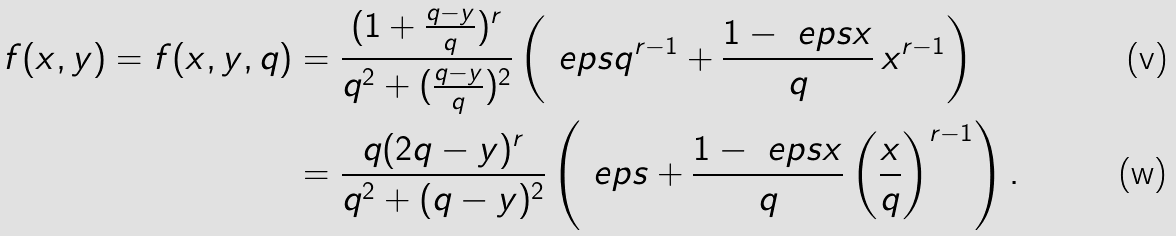Convert formula to latex. <formula><loc_0><loc_0><loc_500><loc_500>f ( x , y ) = f ( x , y , q ) & = \frac { ( 1 + \frac { q - y } { q } ) ^ { r } } { q ^ { 2 } + ( \frac { q - y } { q } ) ^ { 2 } } \left ( \ e p s q ^ { r - 1 } + \frac { 1 - \ e p s x } { q } \, x ^ { r - 1 } \right ) \\ & = \frac { q ( 2 q - y ) ^ { r } } { q ^ { 2 } + ( q - y ) ^ { 2 } } \left ( \ e p s + \frac { 1 - \ e p s x } { q } \left ( \frac { x } { q } \right ) ^ { r - 1 } \right ) .</formula> 